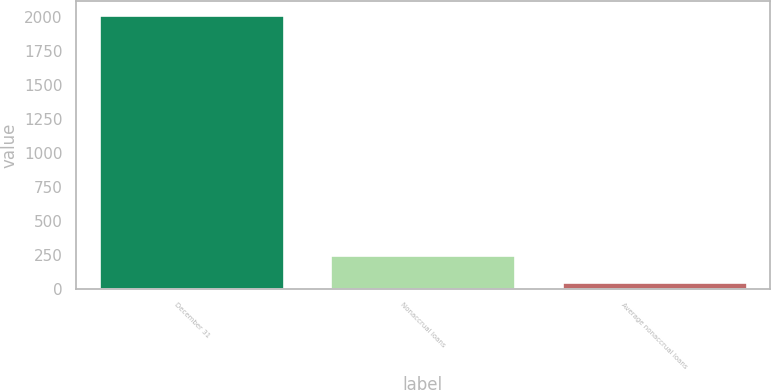Convert chart. <chart><loc_0><loc_0><loc_500><loc_500><bar_chart><fcel>December 31<fcel>Nonaccrual loans<fcel>Average nonaccrual loans<nl><fcel>2011<fcel>247<fcel>51<nl></chart> 